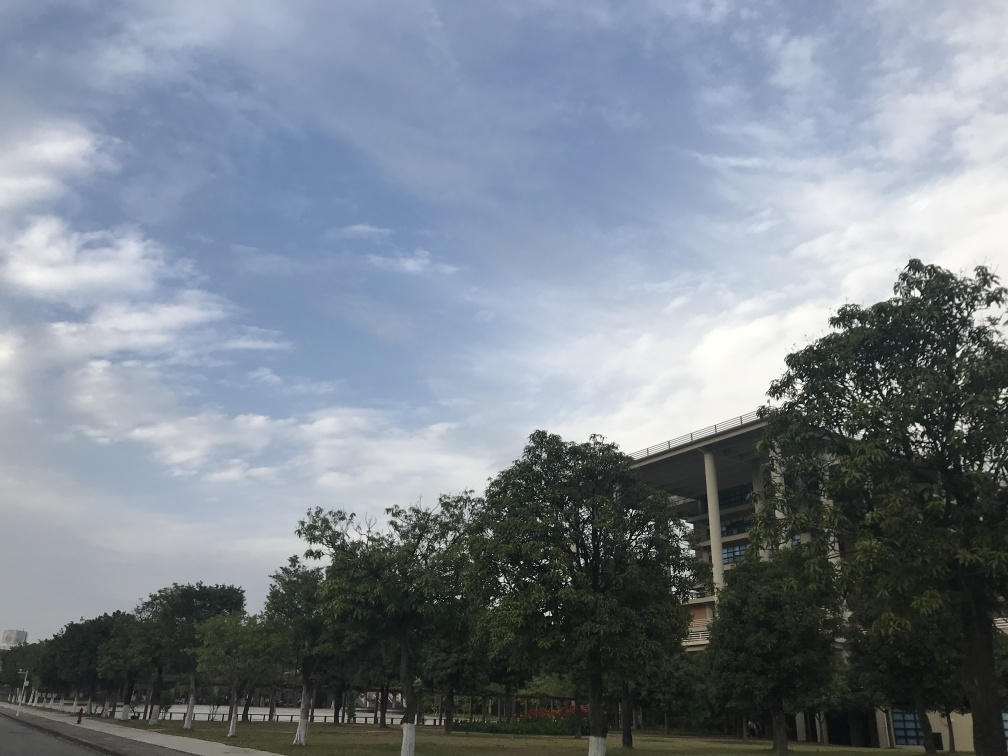What can you infer about the location shown in the picture? Based on the well-maintained greenery, the emptiness of the area, and the modern structure in the background, this location could be a part of a university campus, a corporate park, or a similar institutional area that's designed with open spaces and accessibility in mind. 